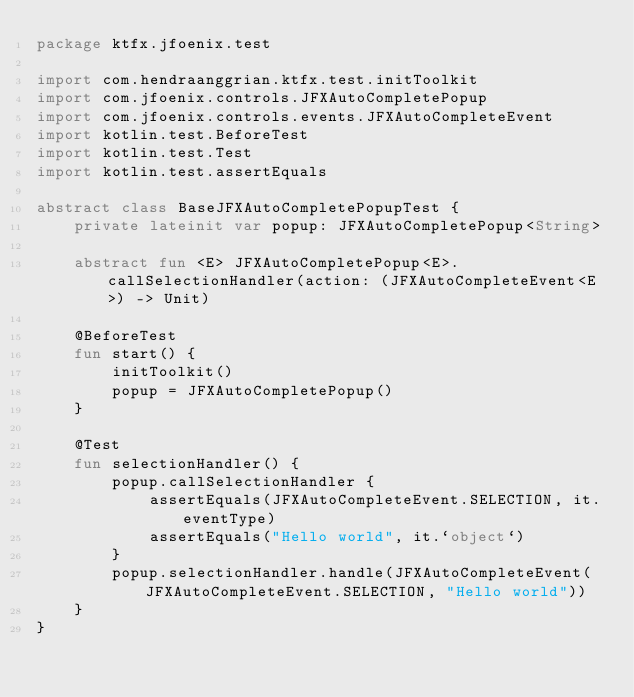<code> <loc_0><loc_0><loc_500><loc_500><_Kotlin_>package ktfx.jfoenix.test

import com.hendraanggrian.ktfx.test.initToolkit
import com.jfoenix.controls.JFXAutoCompletePopup
import com.jfoenix.controls.events.JFXAutoCompleteEvent
import kotlin.test.BeforeTest
import kotlin.test.Test
import kotlin.test.assertEquals

abstract class BaseJFXAutoCompletePopupTest {
    private lateinit var popup: JFXAutoCompletePopup<String>

    abstract fun <E> JFXAutoCompletePopup<E>.callSelectionHandler(action: (JFXAutoCompleteEvent<E>) -> Unit)

    @BeforeTest
    fun start() {
        initToolkit()
        popup = JFXAutoCompletePopup()
    }

    @Test
    fun selectionHandler() {
        popup.callSelectionHandler {
            assertEquals(JFXAutoCompleteEvent.SELECTION, it.eventType)
            assertEquals("Hello world", it.`object`)
        }
        popup.selectionHandler.handle(JFXAutoCompleteEvent(JFXAutoCompleteEvent.SELECTION, "Hello world"))
    }
}</code> 